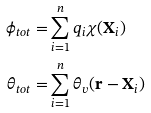Convert formula to latex. <formula><loc_0><loc_0><loc_500><loc_500>\phi _ { t o t } = & \sum _ { i = 1 } ^ { n } q _ { i } \chi ( \mathbf X _ { i } ) \\ \theta _ { t o t } = & \sum _ { i = 1 } ^ { n } \theta _ { v } ( \mathbf r - \mathbf X _ { i } )</formula> 